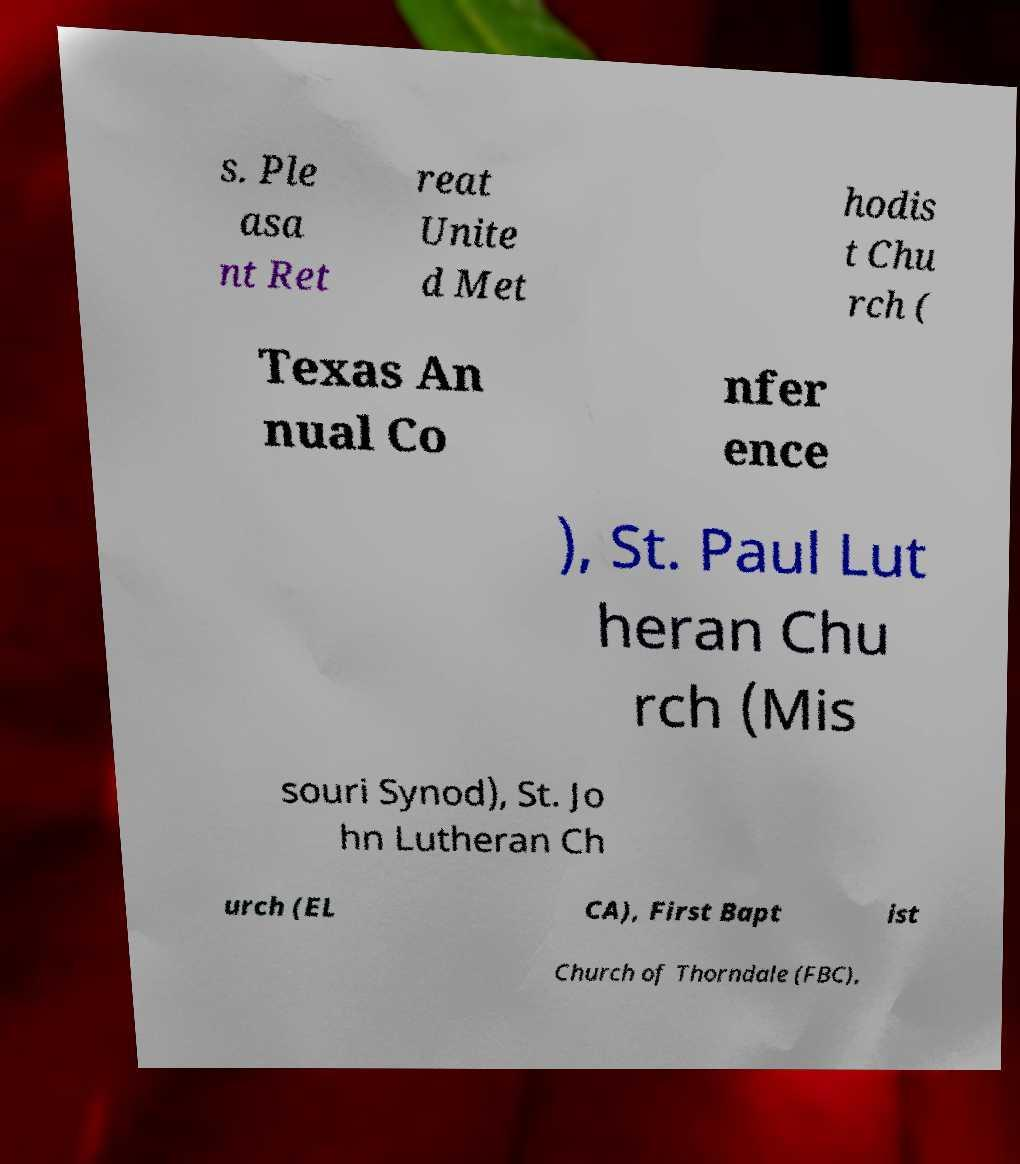Could you assist in decoding the text presented in this image and type it out clearly? s. Ple asa nt Ret reat Unite d Met hodis t Chu rch ( Texas An nual Co nfer ence ), St. Paul Lut heran Chu rch (Mis souri Synod), St. Jo hn Lutheran Ch urch (EL CA), First Bapt ist Church of Thorndale (FBC), 